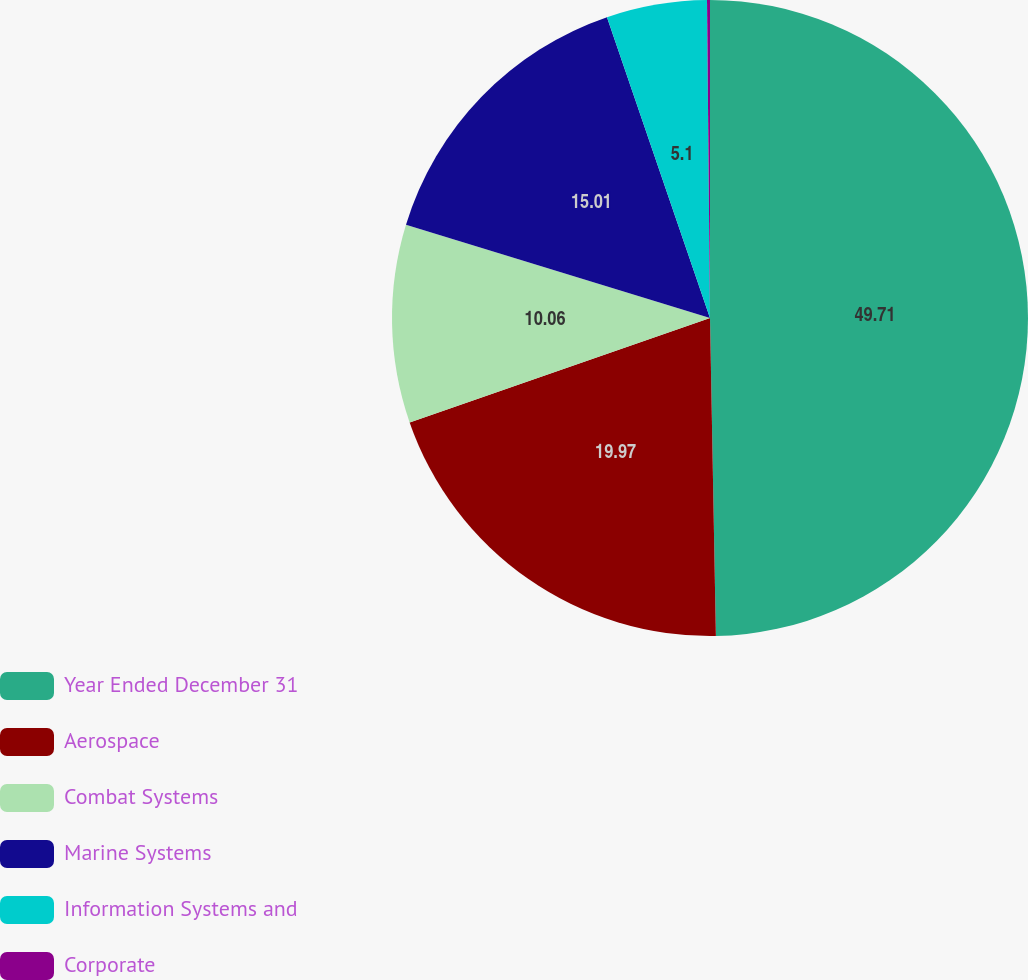Convert chart. <chart><loc_0><loc_0><loc_500><loc_500><pie_chart><fcel>Year Ended December 31<fcel>Aerospace<fcel>Combat Systems<fcel>Marine Systems<fcel>Information Systems and<fcel>Corporate<nl><fcel>49.7%<fcel>19.97%<fcel>10.06%<fcel>15.01%<fcel>5.1%<fcel>0.15%<nl></chart> 